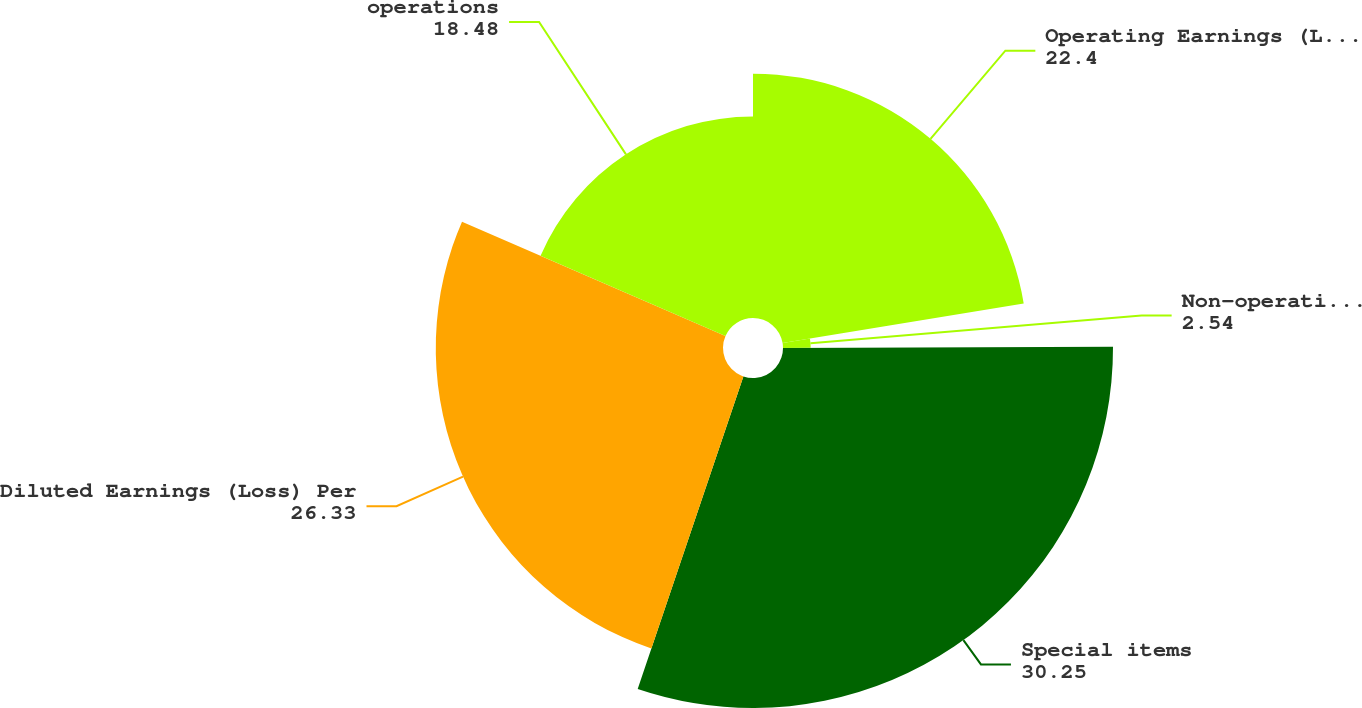Convert chart to OTSL. <chart><loc_0><loc_0><loc_500><loc_500><pie_chart><fcel>Operating Earnings (Loss) Per<fcel>Non-operating pension expense<fcel>Special items<fcel>Diluted Earnings (Loss) Per<fcel>operations<nl><fcel>22.4%<fcel>2.54%<fcel>30.25%<fcel>26.33%<fcel>18.48%<nl></chart> 